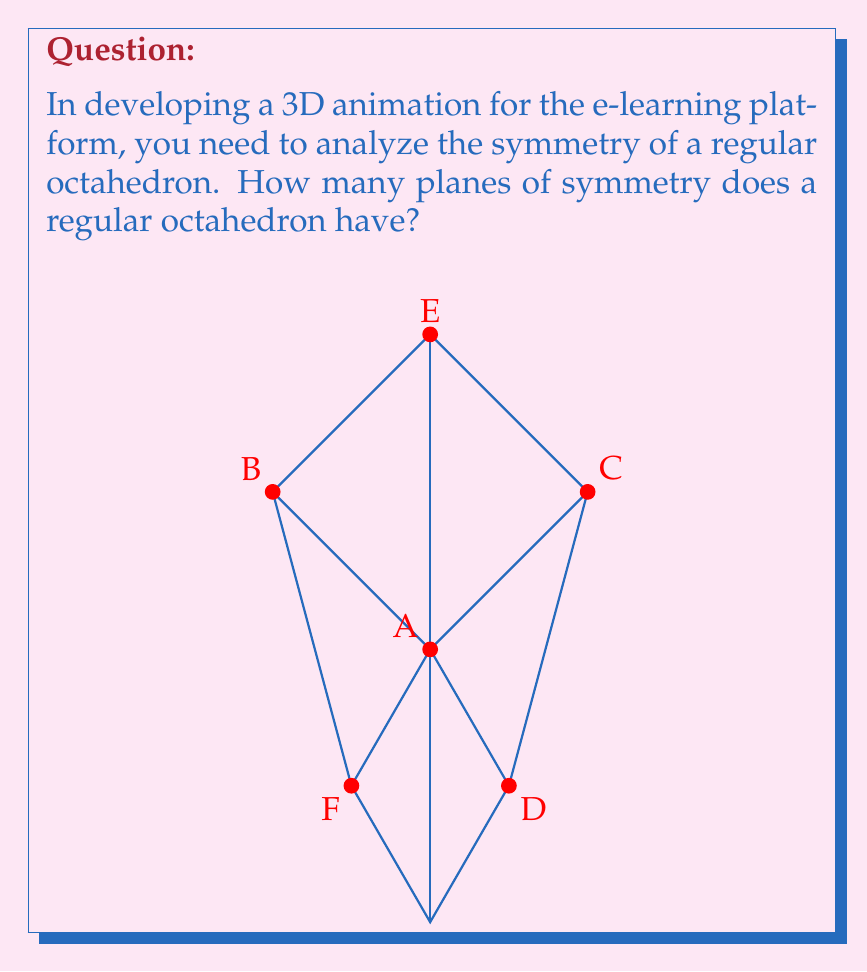Solve this math problem. To determine the number of planes of symmetry in a regular octahedron, let's analyze its structure:

1. Vertex-to-vertex planes:
   - There are 6 vertices in an octahedron.
   - Each pair of opposite vertices defines a plane of symmetry.
   - Number of such planes = $\frac{6}{2} = 3$

2. Edge-to-edge planes:
   - There are 12 edges in an octahedron.
   - Each pair of opposite edges defines a plane of symmetry.
   - Number of such planes = $\frac{12}{2} = 6$

3. Face-to-face planes:
   - There are 8 faces in an octahedron.
   - Each pair of opposite faces defines a plane of symmetry.
   - Number of such planes = $\frac{8}{2} = 4$

To calculate the total number of planes of symmetry:
$$ \text{Total planes} = \text{Vertex-to-vertex} + \text{Edge-to-edge} + \text{Face-to-face} $$
$$ \text{Total planes} = 3 + 6 + 4 = 13 $$

Therefore, a regular octahedron has 13 planes of symmetry.
Answer: 13 planes of symmetry 